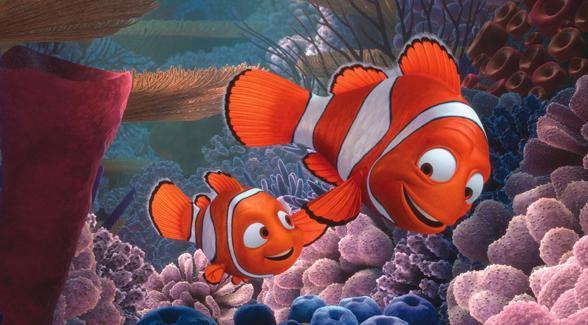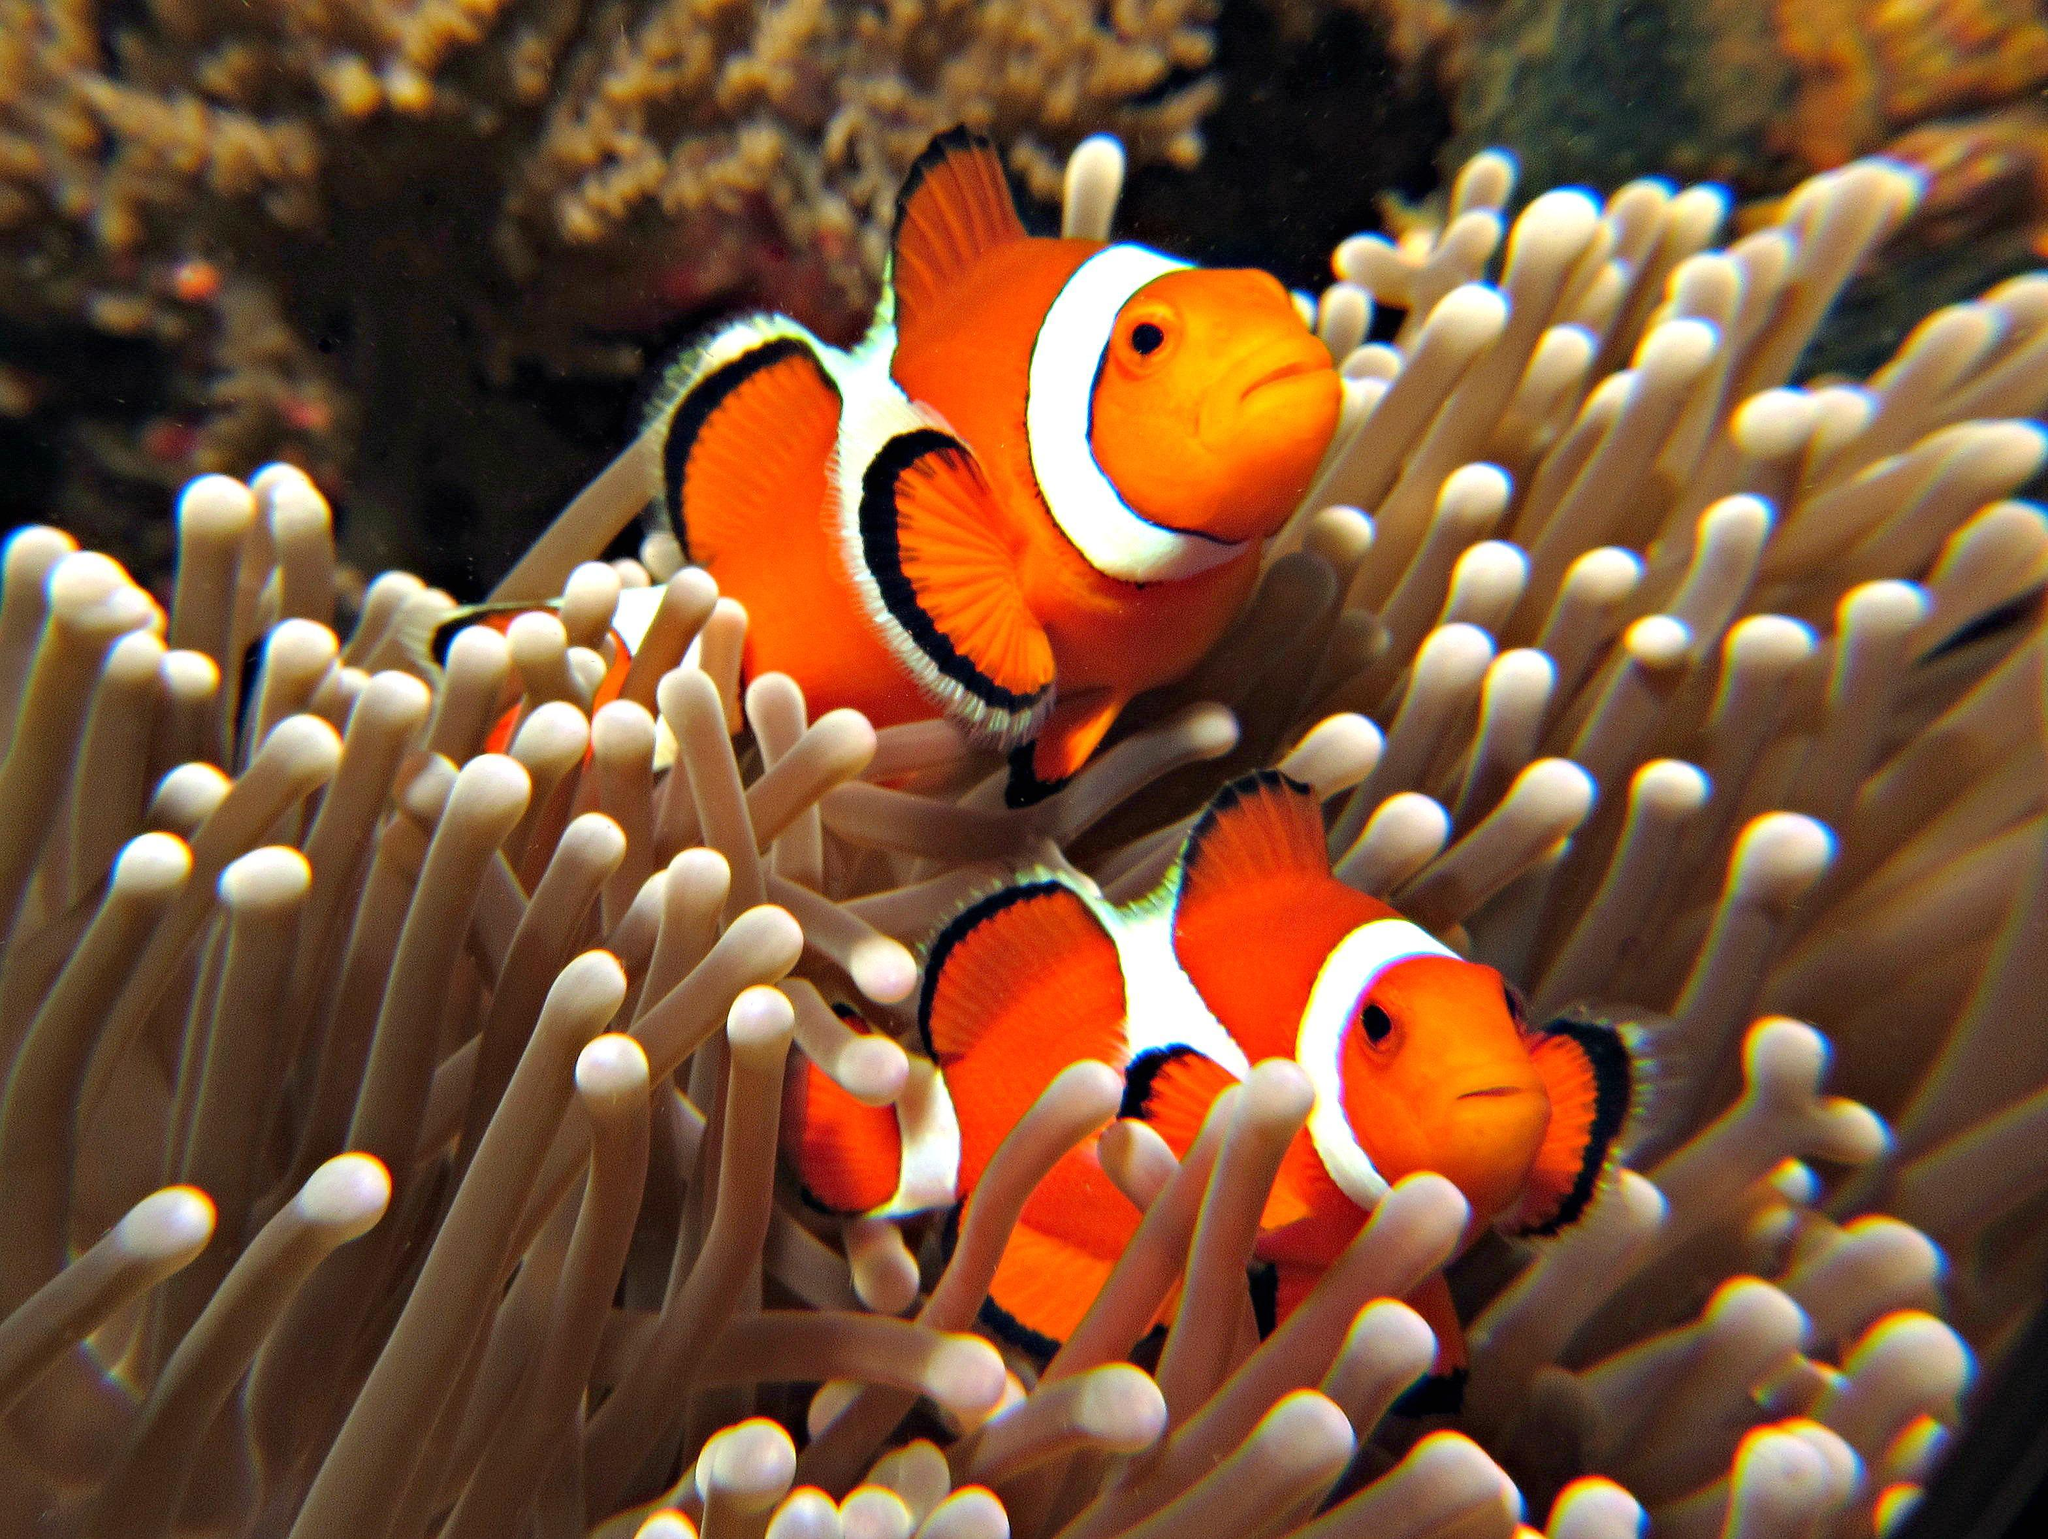The first image is the image on the left, the second image is the image on the right. Analyze the images presented: Is the assertion "There are 4 clownfish." valid? Answer yes or no. Yes. 